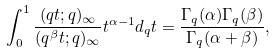<formula> <loc_0><loc_0><loc_500><loc_500>\int _ { 0 } ^ { 1 } \frac { ( q t ; q ) _ { \infty } } { ( q ^ { \beta } t ; q ) _ { \infty } } t ^ { \alpha - 1 } d _ { q } t = \frac { \Gamma _ { q } ( \alpha ) \Gamma _ { q } ( \beta ) } { \Gamma _ { q } ( \alpha + \beta ) } ,</formula> 